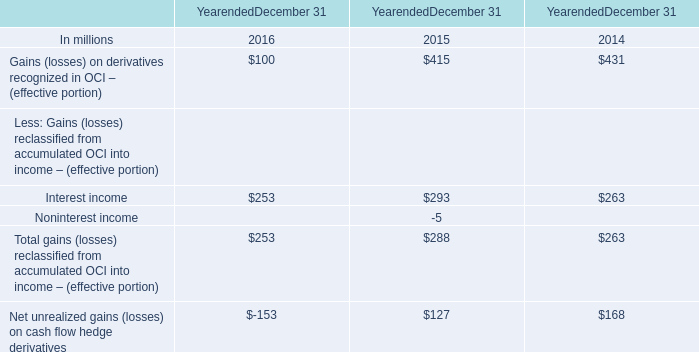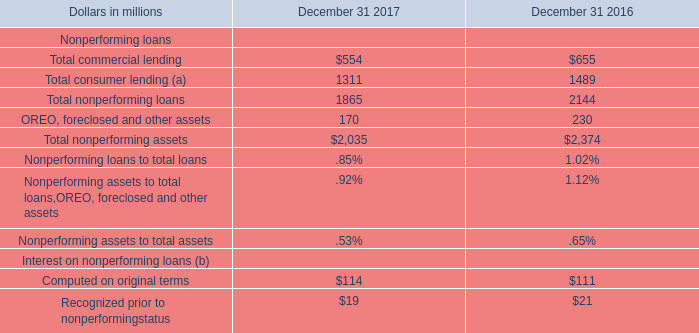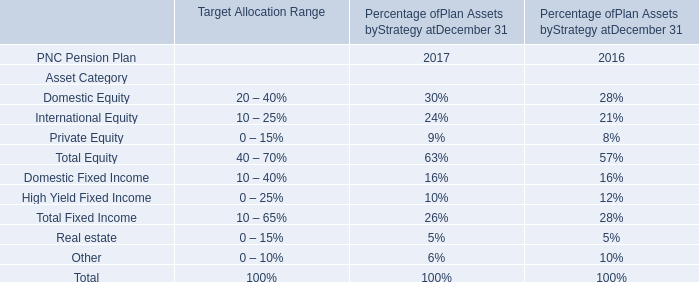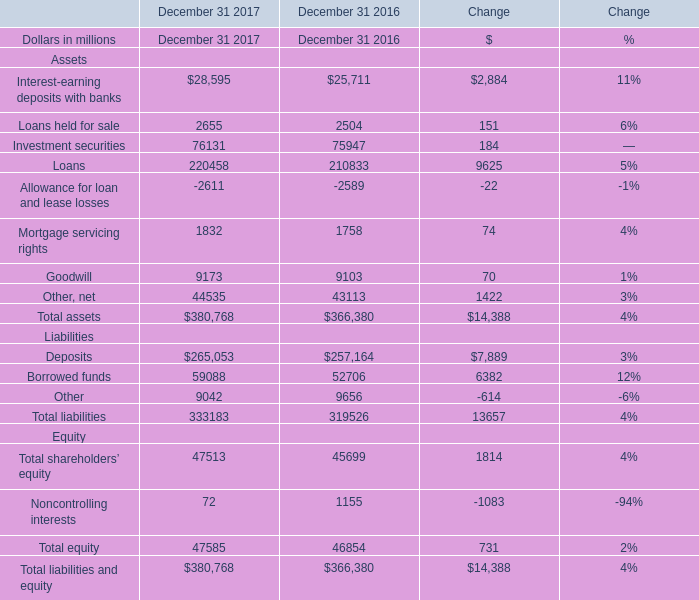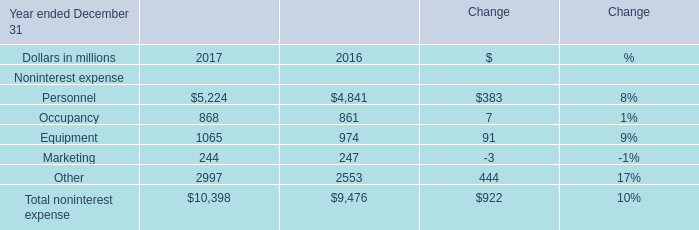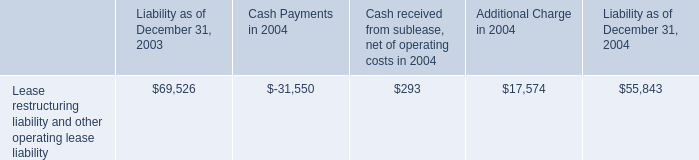What was the total amount of the in the years whereInterest-earning deposits with banks is greater than 1? (in million) 
Computations: (2655 + 2504)
Answer: 5159.0. 